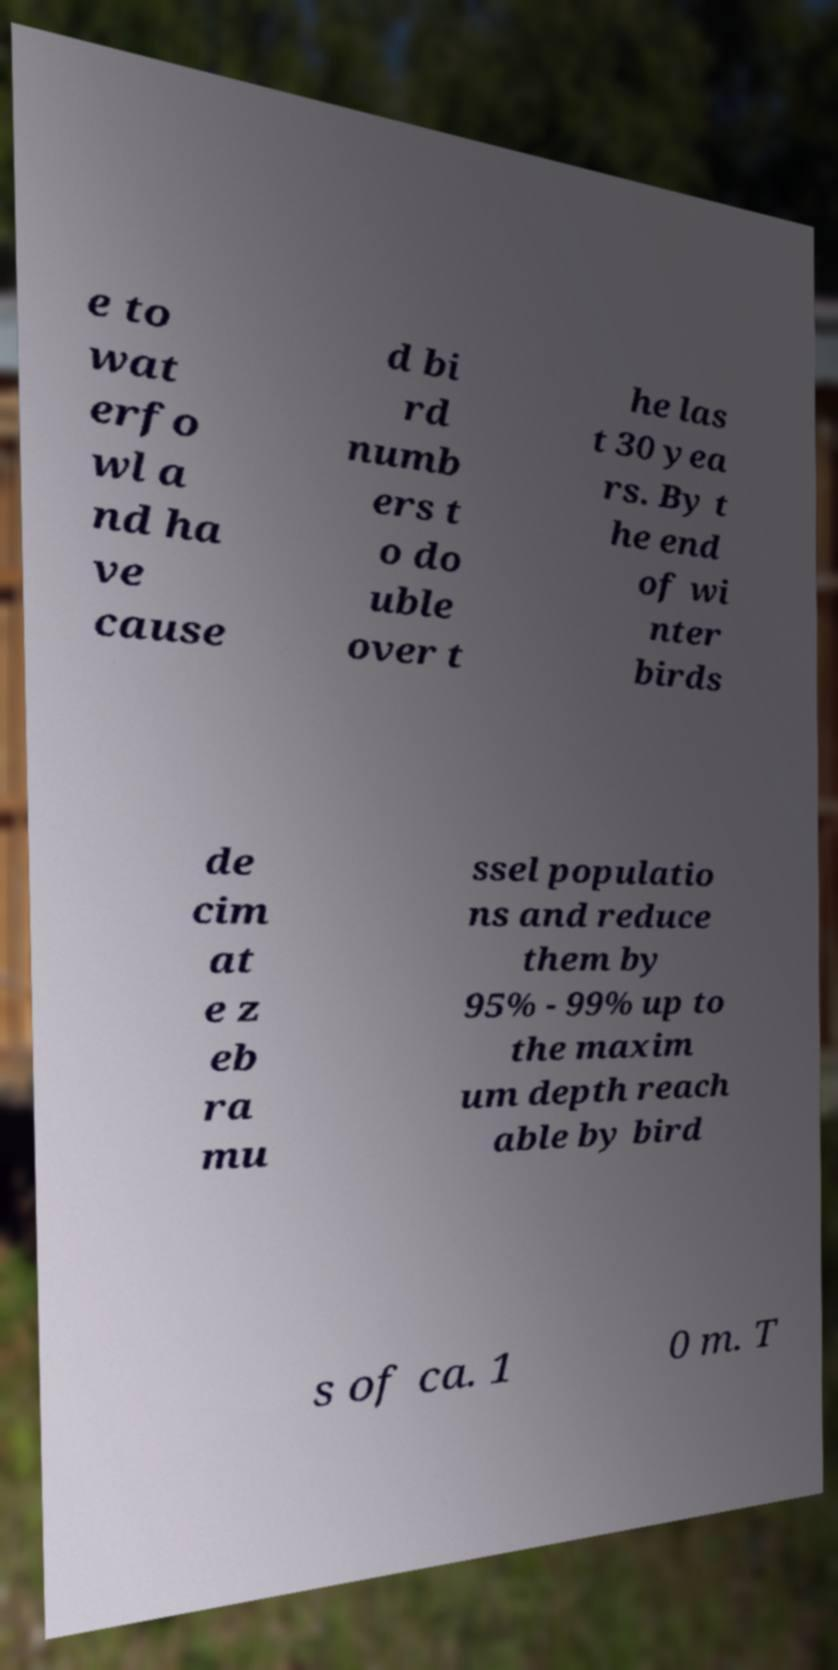For documentation purposes, I need the text within this image transcribed. Could you provide that? e to wat erfo wl a nd ha ve cause d bi rd numb ers t o do uble over t he las t 30 yea rs. By t he end of wi nter birds de cim at e z eb ra mu ssel populatio ns and reduce them by 95% - 99% up to the maxim um depth reach able by bird s of ca. 1 0 m. T 